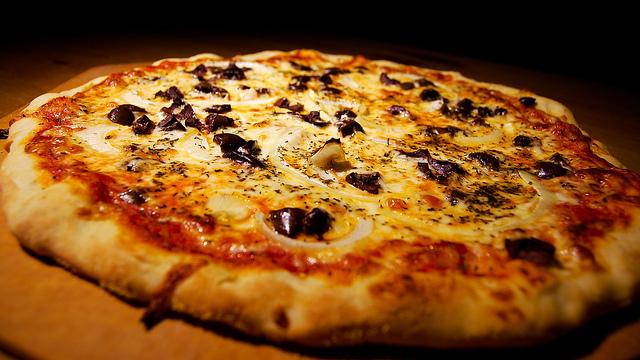Is the crust thin?
Be succinct. No. The pizza doesn't have any toppings?
Quick response, please. No. What food is this?
Short answer required. Pizza. 